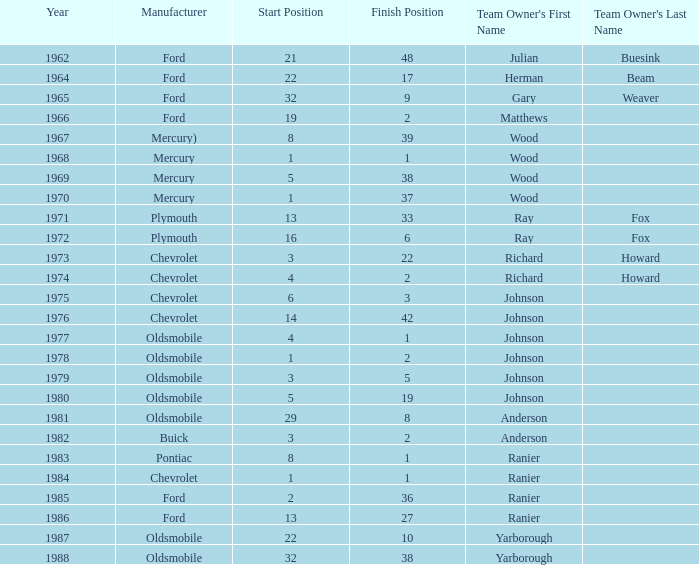What is the smallest finish time for a race where start was less than 3, buick was the manufacturer, and the race was held after 1978? None. 